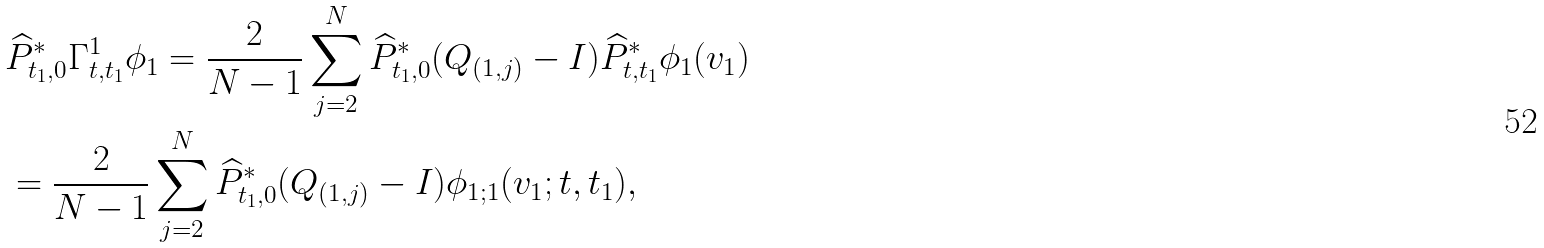<formula> <loc_0><loc_0><loc_500><loc_500>& \widehat { P } ^ { * } _ { t _ { 1 } , 0 } \Gamma ^ { 1 } _ { t , t _ { 1 } } \phi _ { 1 } = \frac { 2 } { N - 1 } \sum _ { j = 2 } ^ { N } \widehat { P } ^ { * } _ { t _ { 1 } , 0 } ( Q _ { ( 1 , j ) } - I ) \widehat { P } ^ { * } _ { t , t _ { 1 } } \phi _ { 1 } ( v _ { 1 } ) \\ & = \frac { 2 } { N - 1 } \sum _ { j = 2 } ^ { N } \widehat { P } ^ { * } _ { t _ { 1 } , 0 } ( Q _ { ( 1 , j ) } - I ) \phi _ { 1 ; 1 } ( v _ { 1 } ; t , t _ { 1 } ) , \\</formula> 